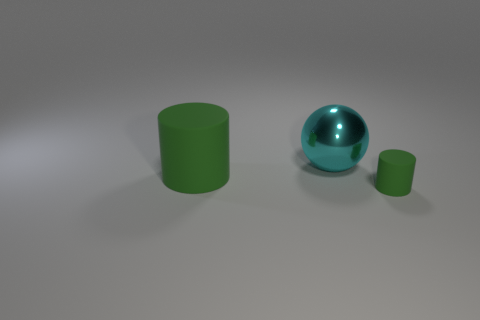How many things are both in front of the large green rubber cylinder and behind the big green rubber cylinder?
Offer a terse response. 0. How many other things are there of the same color as the tiny object?
Provide a succinct answer. 1. What number of green things are matte cylinders or metal cylinders?
Keep it short and to the point. 2. The sphere is what size?
Make the answer very short. Large. How many shiny things are big cylinders or cyan objects?
Your response must be concise. 1. Is the number of tiny green blocks less than the number of big cyan shiny objects?
Give a very brief answer. Yes. What number of other objects are there of the same material as the big cylinder?
Offer a very short reply. 1. What size is the other green rubber thing that is the same shape as the big matte object?
Your answer should be very brief. Small. Are the green cylinder left of the large shiny thing and the green cylinder that is to the right of the big matte object made of the same material?
Your answer should be compact. Yes. Are there fewer green things to the left of the big green rubber object than tiny purple metal blocks?
Keep it short and to the point. No. 